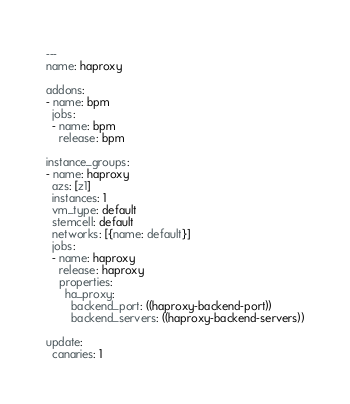<code> <loc_0><loc_0><loc_500><loc_500><_YAML_>---
name: haproxy

addons:
- name: bpm
  jobs:
  - name: bpm
    release: bpm

instance_groups:
- name: haproxy
  azs: [z1]
  instances: 1
  vm_type: default
  stemcell: default
  networks: [{name: default}]
  jobs:
  - name: haproxy
    release: haproxy
    properties:
      ha_proxy:
        backend_port: ((haproxy-backend-port))
        backend_servers: ((haproxy-backend-servers))

update:
  canaries: 1</code> 